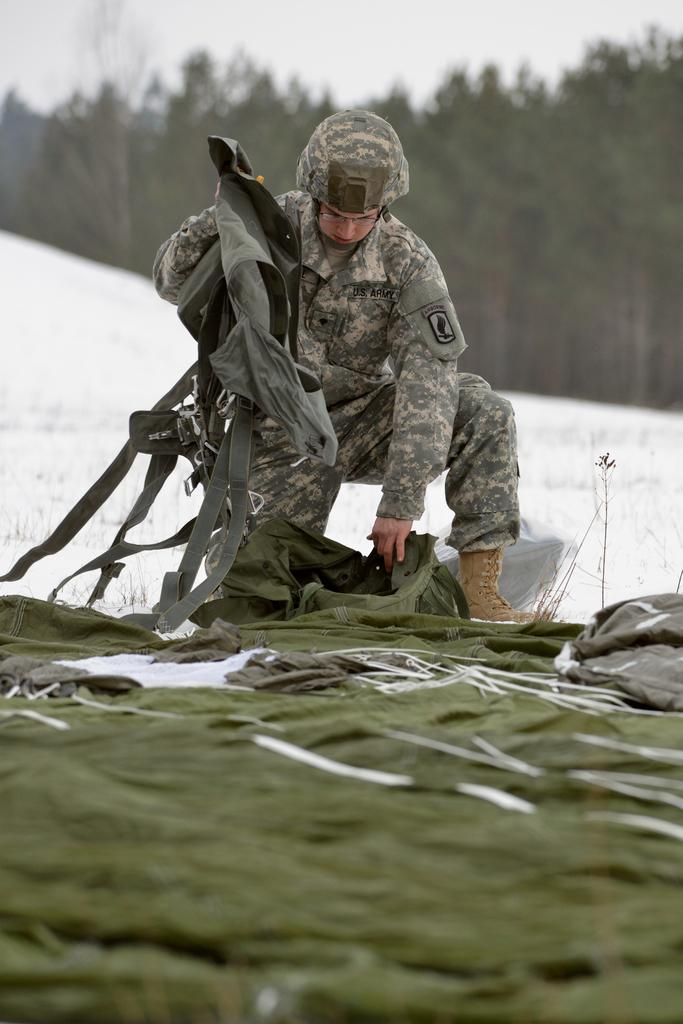What is the main subject of the image? The main subject of the image is a man. What is the man wearing in the image? The man is wearing a dress and a cap in the image. What type of natural vegetation is visible in the image? There are trees visible in the image. What type of stew is the man eating in the image? There is no stew present in the image, and the man's actions are not described. What is the reason behind the man wearing a dress in the image? The reason behind the man wearing a dress in the image is not mentioned or depicted. 